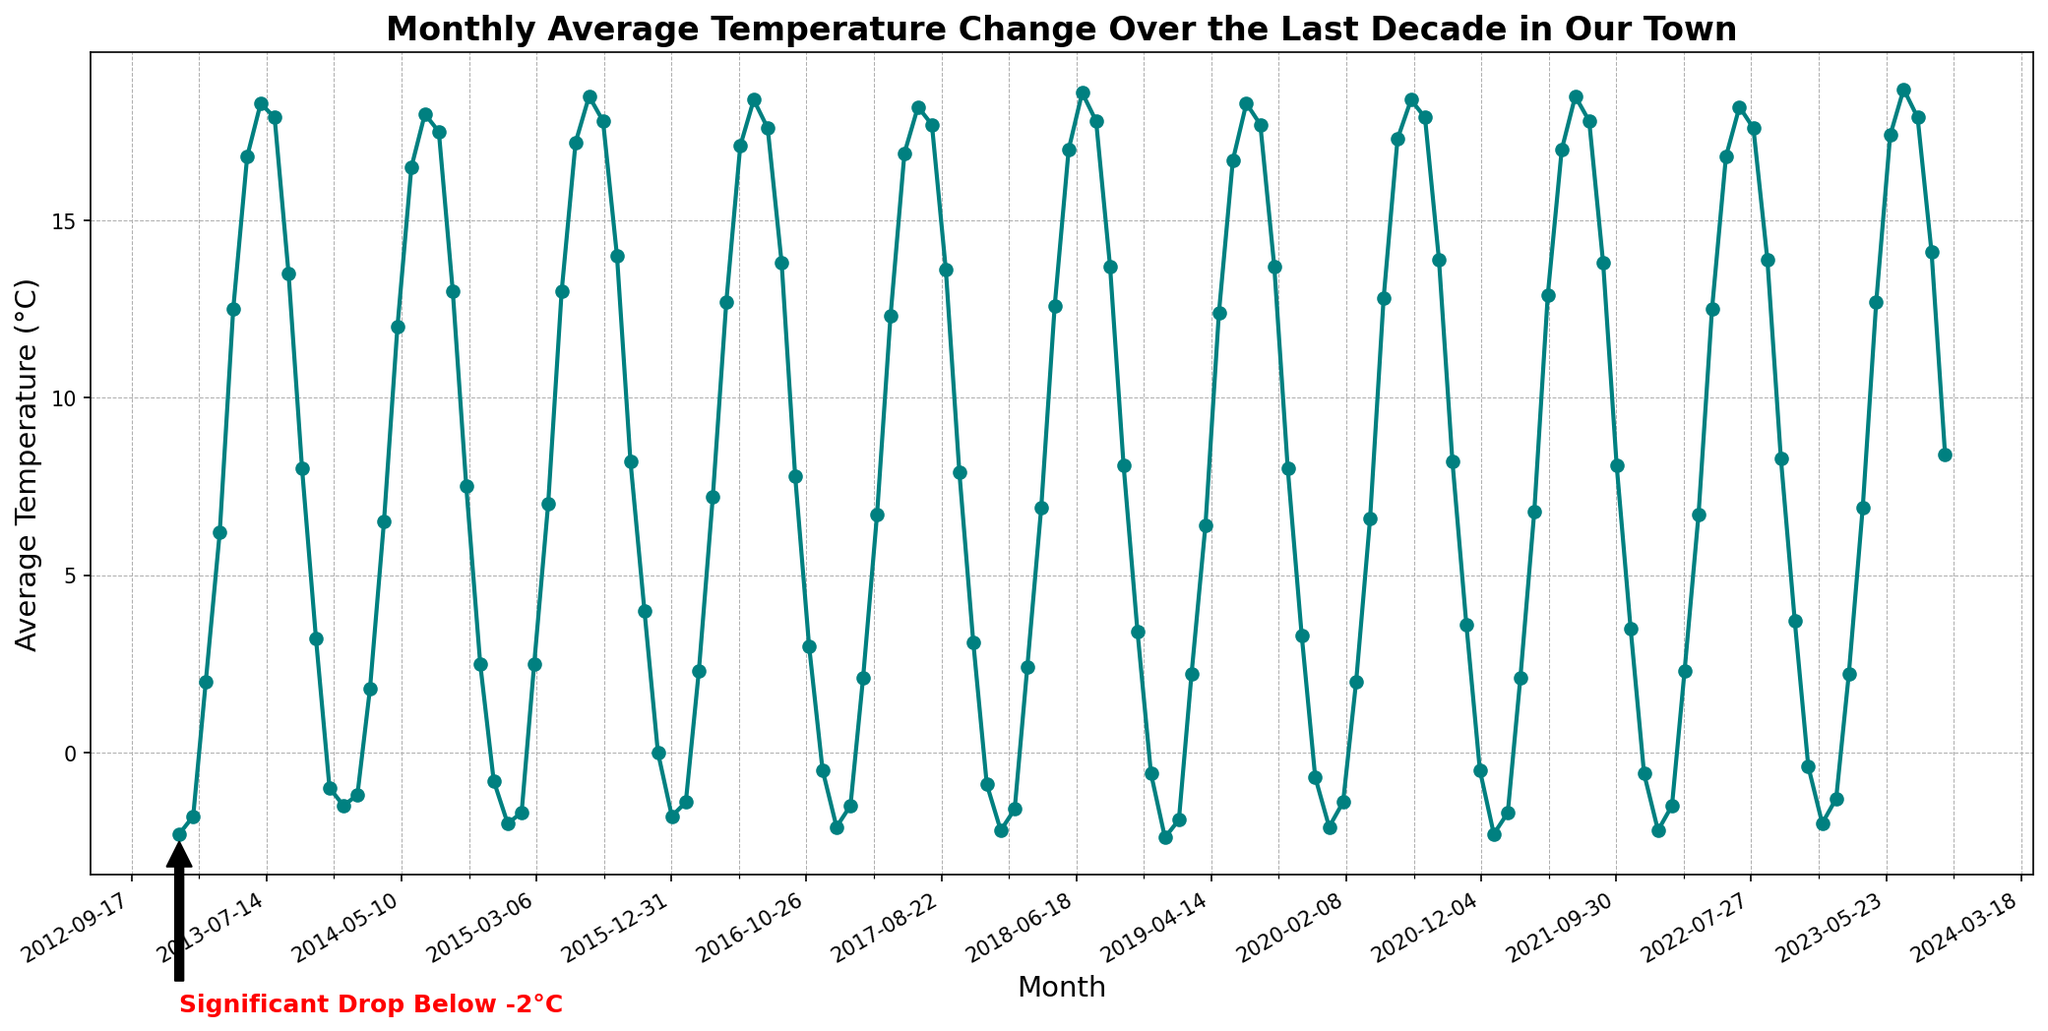What month experienced the highest average temperature in the last decade? Identify the peak on the temperature line. The highest point is observed at July 2023 with an average temperature of 18.7°C.
Answer: July 2023 Which month had a significant drop below -2°C, as highlighted in the figure? Look for the annotation text 'Significant Drop Below -2°C' along with the arrow on the plot, which points to January 2013.
Answer: January 2013 How many years consistently had an average temperature below 0°C in January? Identify all January points and count those below 0°C. These are January 2013, 2014, 2015, 2017, 2018, 2019, 2020, 2021, 2022, and 2023, totaling ten.
Answer: Ten Compare the average temperature of January 2020 with January 2013. Which one is higher? January 2020 is -2.1°C and January 2013 is -2.3°C. Therefore, January 2020 is higher.
Answer: January 2020 What is the difference in average temperature between July 2019 and July 2016? Find July 2019 (18.3°C) and July 2016 (18.4°C), then subtract them: 18.4 - 18.3 = 0.1°C.
Answer: 0.1°C What color is the line representing the monthly average temperature change? Observe the line's color on the plot, which is teal.
Answer: Teal What is the trend in temperature between December 2015 and January 2016? Identify the points for December 2015 (0.0°C) and January 2016 (-1.8°C). There is a decrease observed.
Answer: Decrease Between which months do we see the most significant increase in the average temperature in the year 2013? In 2013, find the months with the most significant increase in temperature values. April 2013 (6.2°C) to May 2013 (12.5°C) shows the largest jump of 6.3°C.
Answer: April to May 2013 What are the visual markers used along the plotted line? Look for the markers used along the plotted line. These are circles.
Answer: Circles 